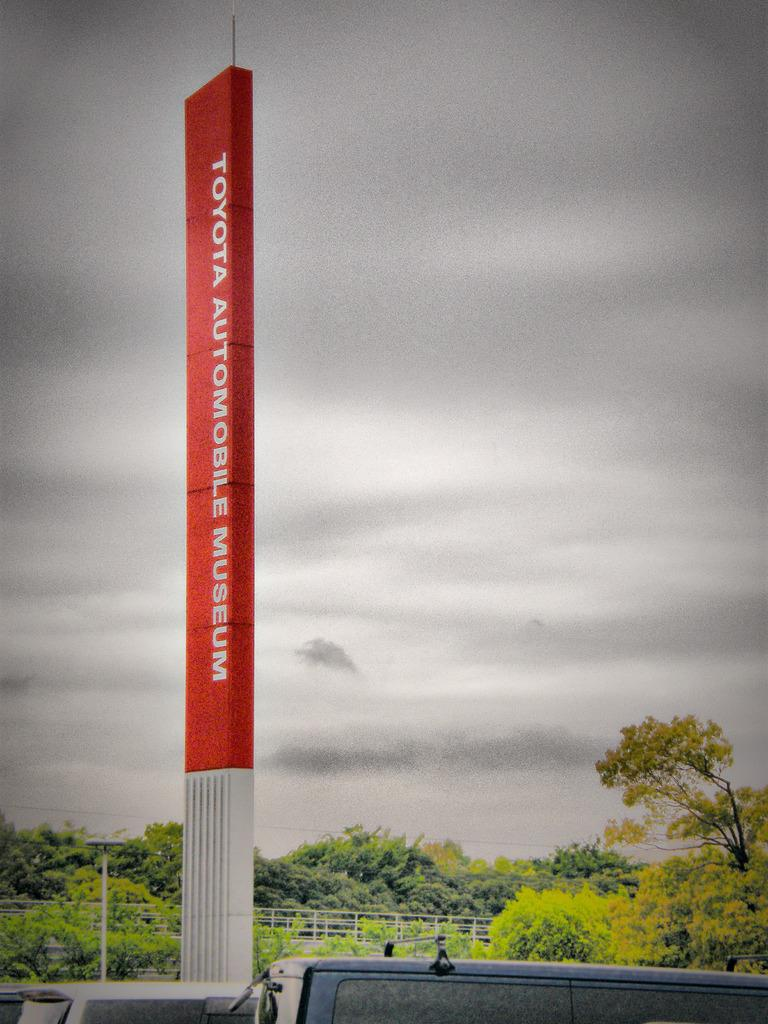<image>
Summarize the visual content of the image. A large vertical sign that reads Toyota Automobile Museum. 